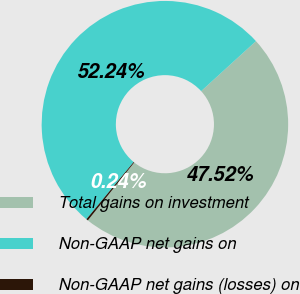<chart> <loc_0><loc_0><loc_500><loc_500><pie_chart><fcel>Total gains on investment<fcel>Non-GAAP net gains on<fcel>Non-GAAP net gains (losses) on<nl><fcel>47.52%<fcel>52.24%<fcel>0.24%<nl></chart> 